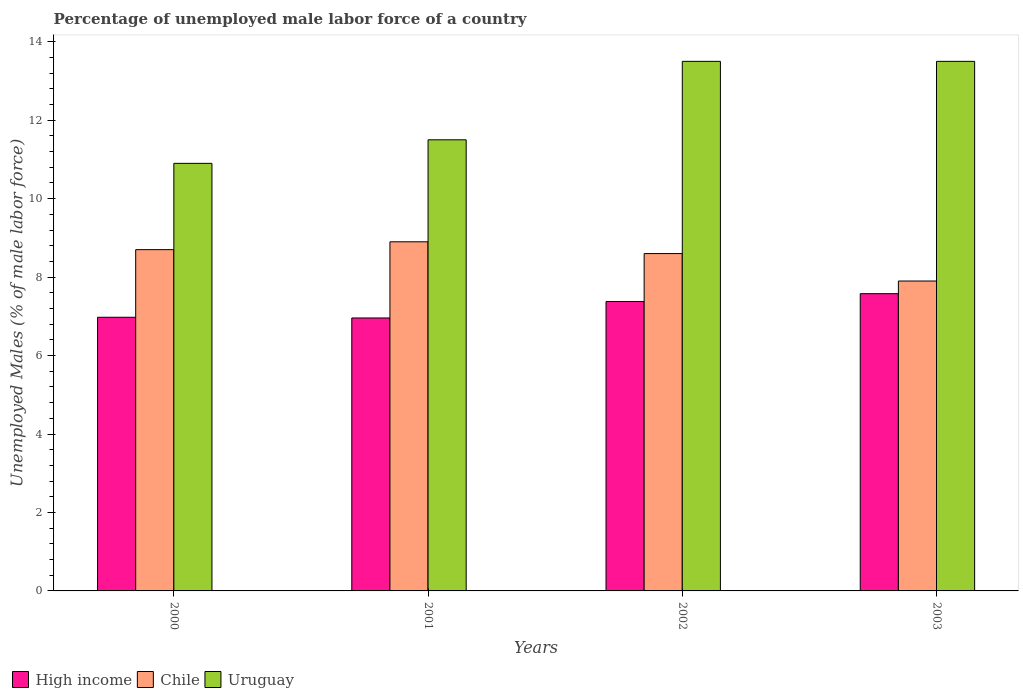How many different coloured bars are there?
Your response must be concise. 3. Are the number of bars on each tick of the X-axis equal?
Offer a terse response. Yes. How many bars are there on the 4th tick from the left?
Your response must be concise. 3. How many bars are there on the 4th tick from the right?
Your response must be concise. 3. What is the label of the 2nd group of bars from the left?
Keep it short and to the point. 2001. In how many cases, is the number of bars for a given year not equal to the number of legend labels?
Provide a short and direct response. 0. What is the percentage of unemployed male labor force in Chile in 2001?
Offer a terse response. 8.9. Across all years, what is the maximum percentage of unemployed male labor force in High income?
Your response must be concise. 7.58. Across all years, what is the minimum percentage of unemployed male labor force in High income?
Your answer should be compact. 6.96. What is the total percentage of unemployed male labor force in Uruguay in the graph?
Offer a very short reply. 49.4. What is the difference between the percentage of unemployed male labor force in High income in 2002 and that in 2003?
Your response must be concise. -0.2. What is the difference between the percentage of unemployed male labor force in Uruguay in 2000 and the percentage of unemployed male labor force in High income in 2002?
Offer a terse response. 3.52. What is the average percentage of unemployed male labor force in Chile per year?
Give a very brief answer. 8.52. In the year 2000, what is the difference between the percentage of unemployed male labor force in High income and percentage of unemployed male labor force in Uruguay?
Your response must be concise. -3.92. What is the ratio of the percentage of unemployed male labor force in Chile in 2002 to that in 2003?
Offer a very short reply. 1.09. Is the percentage of unemployed male labor force in Uruguay in 2001 less than that in 2003?
Provide a short and direct response. Yes. What is the difference between the highest and the second highest percentage of unemployed male labor force in High income?
Keep it short and to the point. 0.2. What is the difference between the highest and the lowest percentage of unemployed male labor force in Uruguay?
Your answer should be very brief. 2.6. What does the 1st bar from the left in 2001 represents?
Your answer should be compact. High income. Is it the case that in every year, the sum of the percentage of unemployed male labor force in Uruguay and percentage of unemployed male labor force in High income is greater than the percentage of unemployed male labor force in Chile?
Give a very brief answer. Yes. How many years are there in the graph?
Your answer should be very brief. 4. What is the difference between two consecutive major ticks on the Y-axis?
Make the answer very short. 2. Where does the legend appear in the graph?
Your answer should be very brief. Bottom left. How are the legend labels stacked?
Your answer should be very brief. Horizontal. What is the title of the graph?
Provide a short and direct response. Percentage of unemployed male labor force of a country. Does "Faeroe Islands" appear as one of the legend labels in the graph?
Keep it short and to the point. No. What is the label or title of the X-axis?
Provide a short and direct response. Years. What is the label or title of the Y-axis?
Your response must be concise. Unemployed Males (% of male labor force). What is the Unemployed Males (% of male labor force) of High income in 2000?
Your response must be concise. 6.98. What is the Unemployed Males (% of male labor force) in Chile in 2000?
Provide a short and direct response. 8.7. What is the Unemployed Males (% of male labor force) in Uruguay in 2000?
Give a very brief answer. 10.9. What is the Unemployed Males (% of male labor force) of High income in 2001?
Your response must be concise. 6.96. What is the Unemployed Males (% of male labor force) in Chile in 2001?
Keep it short and to the point. 8.9. What is the Unemployed Males (% of male labor force) in High income in 2002?
Your answer should be very brief. 7.38. What is the Unemployed Males (% of male labor force) of Chile in 2002?
Keep it short and to the point. 8.6. What is the Unemployed Males (% of male labor force) in High income in 2003?
Offer a terse response. 7.58. What is the Unemployed Males (% of male labor force) in Chile in 2003?
Your answer should be very brief. 7.9. What is the Unemployed Males (% of male labor force) in Uruguay in 2003?
Offer a very short reply. 13.5. Across all years, what is the maximum Unemployed Males (% of male labor force) in High income?
Your response must be concise. 7.58. Across all years, what is the maximum Unemployed Males (% of male labor force) in Chile?
Your answer should be compact. 8.9. Across all years, what is the minimum Unemployed Males (% of male labor force) in High income?
Your answer should be very brief. 6.96. Across all years, what is the minimum Unemployed Males (% of male labor force) in Chile?
Your answer should be compact. 7.9. Across all years, what is the minimum Unemployed Males (% of male labor force) in Uruguay?
Keep it short and to the point. 10.9. What is the total Unemployed Males (% of male labor force) of High income in the graph?
Give a very brief answer. 28.89. What is the total Unemployed Males (% of male labor force) of Chile in the graph?
Your answer should be very brief. 34.1. What is the total Unemployed Males (% of male labor force) of Uruguay in the graph?
Provide a succinct answer. 49.4. What is the difference between the Unemployed Males (% of male labor force) of High income in 2000 and that in 2001?
Ensure brevity in your answer.  0.02. What is the difference between the Unemployed Males (% of male labor force) in Uruguay in 2000 and that in 2001?
Your answer should be compact. -0.6. What is the difference between the Unemployed Males (% of male labor force) in High income in 2000 and that in 2002?
Ensure brevity in your answer.  -0.4. What is the difference between the Unemployed Males (% of male labor force) in Chile in 2000 and that in 2002?
Your answer should be compact. 0.1. What is the difference between the Unemployed Males (% of male labor force) in High income in 2000 and that in 2003?
Provide a short and direct response. -0.6. What is the difference between the Unemployed Males (% of male labor force) in Chile in 2000 and that in 2003?
Offer a terse response. 0.8. What is the difference between the Unemployed Males (% of male labor force) in High income in 2001 and that in 2002?
Your answer should be compact. -0.42. What is the difference between the Unemployed Males (% of male labor force) of Chile in 2001 and that in 2002?
Keep it short and to the point. 0.3. What is the difference between the Unemployed Males (% of male labor force) in High income in 2001 and that in 2003?
Give a very brief answer. -0.62. What is the difference between the Unemployed Males (% of male labor force) in Uruguay in 2001 and that in 2003?
Offer a very short reply. -2. What is the difference between the Unemployed Males (% of male labor force) in High income in 2002 and that in 2003?
Provide a succinct answer. -0.2. What is the difference between the Unemployed Males (% of male labor force) of Chile in 2002 and that in 2003?
Make the answer very short. 0.7. What is the difference between the Unemployed Males (% of male labor force) in Uruguay in 2002 and that in 2003?
Offer a very short reply. 0. What is the difference between the Unemployed Males (% of male labor force) in High income in 2000 and the Unemployed Males (% of male labor force) in Chile in 2001?
Keep it short and to the point. -1.92. What is the difference between the Unemployed Males (% of male labor force) in High income in 2000 and the Unemployed Males (% of male labor force) in Uruguay in 2001?
Your response must be concise. -4.52. What is the difference between the Unemployed Males (% of male labor force) of Chile in 2000 and the Unemployed Males (% of male labor force) of Uruguay in 2001?
Make the answer very short. -2.8. What is the difference between the Unemployed Males (% of male labor force) of High income in 2000 and the Unemployed Males (% of male labor force) of Chile in 2002?
Offer a terse response. -1.62. What is the difference between the Unemployed Males (% of male labor force) of High income in 2000 and the Unemployed Males (% of male labor force) of Uruguay in 2002?
Offer a very short reply. -6.52. What is the difference between the Unemployed Males (% of male labor force) of Chile in 2000 and the Unemployed Males (% of male labor force) of Uruguay in 2002?
Provide a succinct answer. -4.8. What is the difference between the Unemployed Males (% of male labor force) in High income in 2000 and the Unemployed Males (% of male labor force) in Chile in 2003?
Offer a very short reply. -0.92. What is the difference between the Unemployed Males (% of male labor force) of High income in 2000 and the Unemployed Males (% of male labor force) of Uruguay in 2003?
Ensure brevity in your answer.  -6.52. What is the difference between the Unemployed Males (% of male labor force) in High income in 2001 and the Unemployed Males (% of male labor force) in Chile in 2002?
Ensure brevity in your answer.  -1.64. What is the difference between the Unemployed Males (% of male labor force) in High income in 2001 and the Unemployed Males (% of male labor force) in Uruguay in 2002?
Keep it short and to the point. -6.54. What is the difference between the Unemployed Males (% of male labor force) in High income in 2001 and the Unemployed Males (% of male labor force) in Chile in 2003?
Offer a terse response. -0.94. What is the difference between the Unemployed Males (% of male labor force) in High income in 2001 and the Unemployed Males (% of male labor force) in Uruguay in 2003?
Your response must be concise. -6.54. What is the difference between the Unemployed Males (% of male labor force) in Chile in 2001 and the Unemployed Males (% of male labor force) in Uruguay in 2003?
Make the answer very short. -4.6. What is the difference between the Unemployed Males (% of male labor force) in High income in 2002 and the Unemployed Males (% of male labor force) in Chile in 2003?
Your answer should be very brief. -0.52. What is the difference between the Unemployed Males (% of male labor force) of High income in 2002 and the Unemployed Males (% of male labor force) of Uruguay in 2003?
Your answer should be compact. -6.12. What is the average Unemployed Males (% of male labor force) in High income per year?
Your response must be concise. 7.22. What is the average Unemployed Males (% of male labor force) of Chile per year?
Keep it short and to the point. 8.53. What is the average Unemployed Males (% of male labor force) of Uruguay per year?
Provide a succinct answer. 12.35. In the year 2000, what is the difference between the Unemployed Males (% of male labor force) of High income and Unemployed Males (% of male labor force) of Chile?
Offer a very short reply. -1.72. In the year 2000, what is the difference between the Unemployed Males (% of male labor force) in High income and Unemployed Males (% of male labor force) in Uruguay?
Provide a succinct answer. -3.92. In the year 2001, what is the difference between the Unemployed Males (% of male labor force) of High income and Unemployed Males (% of male labor force) of Chile?
Make the answer very short. -1.94. In the year 2001, what is the difference between the Unemployed Males (% of male labor force) of High income and Unemployed Males (% of male labor force) of Uruguay?
Keep it short and to the point. -4.54. In the year 2001, what is the difference between the Unemployed Males (% of male labor force) of Chile and Unemployed Males (% of male labor force) of Uruguay?
Your answer should be compact. -2.6. In the year 2002, what is the difference between the Unemployed Males (% of male labor force) of High income and Unemployed Males (% of male labor force) of Chile?
Give a very brief answer. -1.22. In the year 2002, what is the difference between the Unemployed Males (% of male labor force) in High income and Unemployed Males (% of male labor force) in Uruguay?
Offer a very short reply. -6.12. In the year 2002, what is the difference between the Unemployed Males (% of male labor force) in Chile and Unemployed Males (% of male labor force) in Uruguay?
Offer a very short reply. -4.9. In the year 2003, what is the difference between the Unemployed Males (% of male labor force) of High income and Unemployed Males (% of male labor force) of Chile?
Your answer should be compact. -0.32. In the year 2003, what is the difference between the Unemployed Males (% of male labor force) of High income and Unemployed Males (% of male labor force) of Uruguay?
Offer a terse response. -5.92. What is the ratio of the Unemployed Males (% of male labor force) in High income in 2000 to that in 2001?
Provide a succinct answer. 1. What is the ratio of the Unemployed Males (% of male labor force) in Chile in 2000 to that in 2001?
Your response must be concise. 0.98. What is the ratio of the Unemployed Males (% of male labor force) in Uruguay in 2000 to that in 2001?
Ensure brevity in your answer.  0.95. What is the ratio of the Unemployed Males (% of male labor force) in High income in 2000 to that in 2002?
Provide a short and direct response. 0.95. What is the ratio of the Unemployed Males (% of male labor force) of Chile in 2000 to that in 2002?
Offer a very short reply. 1.01. What is the ratio of the Unemployed Males (% of male labor force) in Uruguay in 2000 to that in 2002?
Your response must be concise. 0.81. What is the ratio of the Unemployed Males (% of male labor force) in High income in 2000 to that in 2003?
Your answer should be compact. 0.92. What is the ratio of the Unemployed Males (% of male labor force) in Chile in 2000 to that in 2003?
Keep it short and to the point. 1.1. What is the ratio of the Unemployed Males (% of male labor force) of Uruguay in 2000 to that in 2003?
Provide a succinct answer. 0.81. What is the ratio of the Unemployed Males (% of male labor force) in High income in 2001 to that in 2002?
Your answer should be compact. 0.94. What is the ratio of the Unemployed Males (% of male labor force) in Chile in 2001 to that in 2002?
Keep it short and to the point. 1.03. What is the ratio of the Unemployed Males (% of male labor force) in Uruguay in 2001 to that in 2002?
Ensure brevity in your answer.  0.85. What is the ratio of the Unemployed Males (% of male labor force) in High income in 2001 to that in 2003?
Ensure brevity in your answer.  0.92. What is the ratio of the Unemployed Males (% of male labor force) in Chile in 2001 to that in 2003?
Provide a succinct answer. 1.13. What is the ratio of the Unemployed Males (% of male labor force) of Uruguay in 2001 to that in 2003?
Make the answer very short. 0.85. What is the ratio of the Unemployed Males (% of male labor force) in High income in 2002 to that in 2003?
Your answer should be very brief. 0.97. What is the ratio of the Unemployed Males (% of male labor force) in Chile in 2002 to that in 2003?
Provide a succinct answer. 1.09. What is the ratio of the Unemployed Males (% of male labor force) of Uruguay in 2002 to that in 2003?
Give a very brief answer. 1. What is the difference between the highest and the second highest Unemployed Males (% of male labor force) in High income?
Keep it short and to the point. 0.2. What is the difference between the highest and the second highest Unemployed Males (% of male labor force) in Chile?
Make the answer very short. 0.2. What is the difference between the highest and the second highest Unemployed Males (% of male labor force) of Uruguay?
Make the answer very short. 0. What is the difference between the highest and the lowest Unemployed Males (% of male labor force) of High income?
Provide a short and direct response. 0.62. 